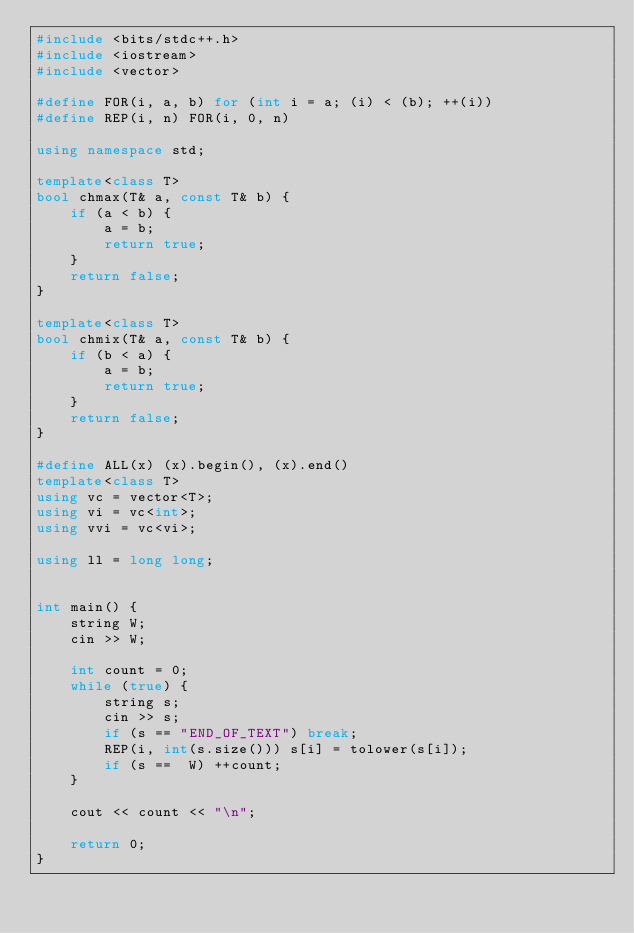<code> <loc_0><loc_0><loc_500><loc_500><_C++_>#include <bits/stdc++.h>
#include <iostream>
#include <vector>

#define FOR(i, a, b) for (int i = a; (i) < (b); ++(i))
#define REP(i, n) FOR(i, 0, n)

using namespace std;

template<class T>
bool chmax(T& a, const T& b) {
    if (a < b) {
        a = b;
        return true;
    }
    return false;
}

template<class T>
bool chmix(T& a, const T& b) {
    if (b < a) {
        a = b;
        return true;
    }
    return false;
}

#define ALL(x) (x).begin(), (x).end()
template<class T>
using vc = vector<T>;
using vi = vc<int>;
using vvi = vc<vi>;

using ll = long long;


int main() {
    string W;
    cin >> W;

    int count = 0;
    while (true) {
        string s;
        cin >> s;
        if (s == "END_OF_TEXT") break;
        REP(i, int(s.size())) s[i] = tolower(s[i]);
        if (s ==  W) ++count;
    }

    cout << count << "\n";

    return 0;
}

</code> 